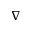<formula> <loc_0><loc_0><loc_500><loc_500>\nabla</formula> 